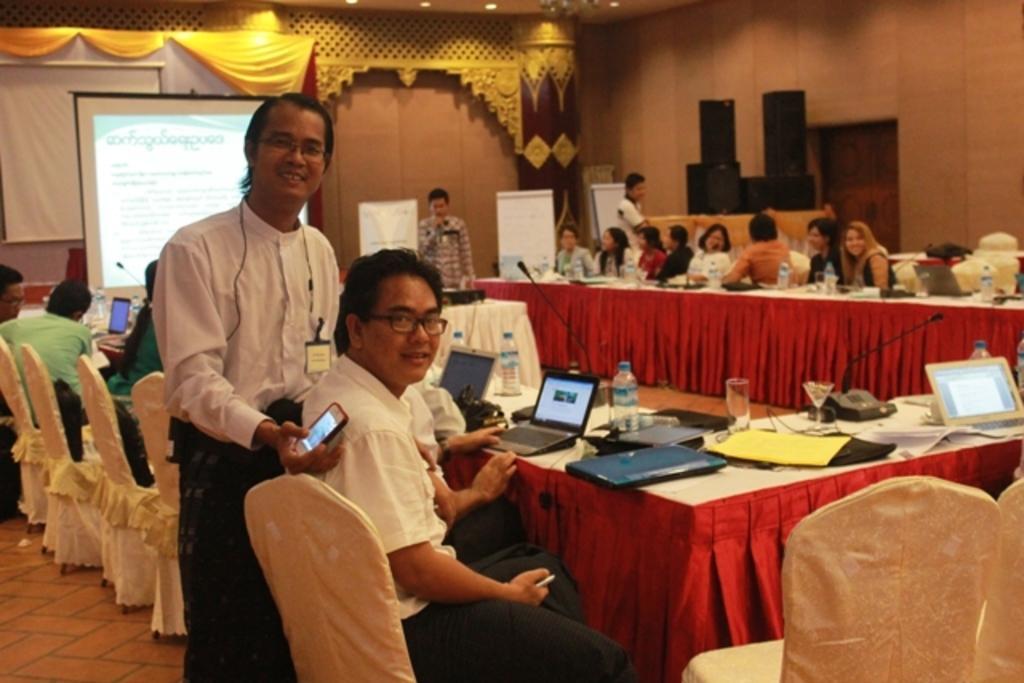Could you give a brief overview of what you see in this image? In this image in the front there is a person standing and holding a mobile phone in his hand and smiling. In the center there are persons sitting and there is a table and on the table there are laptops, bottles and glasses and mics. In the background there are persons standing, there are boards which are white in colour with some text on it and there are speakers which are black in colour and there is a stage. 